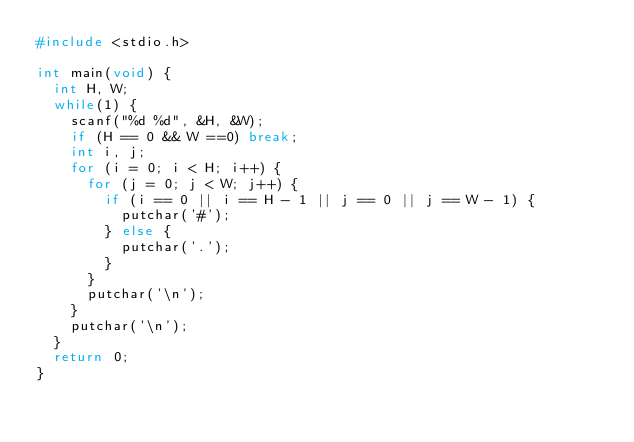Convert code to text. <code><loc_0><loc_0><loc_500><loc_500><_C_>#include <stdio.h>

int main(void) {
  int H, W;
  while(1) {
    scanf("%d %d", &H, &W);
    if (H == 0 && W ==0) break;
    int i, j;
    for (i = 0; i < H; i++) {
      for (j = 0; j < W; j++) {
        if (i == 0 || i == H - 1 || j == 0 || j == W - 1) {
          putchar('#');
        } else {
          putchar('.');
        }
      }
      putchar('\n');
    }
    putchar('\n');
  }
  return 0;
}
</code> 